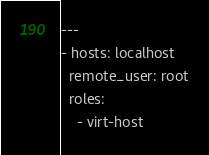<code> <loc_0><loc_0><loc_500><loc_500><_YAML_>---
- hosts: localhost
  remote_user: root
  roles:
    - virt-host</code> 